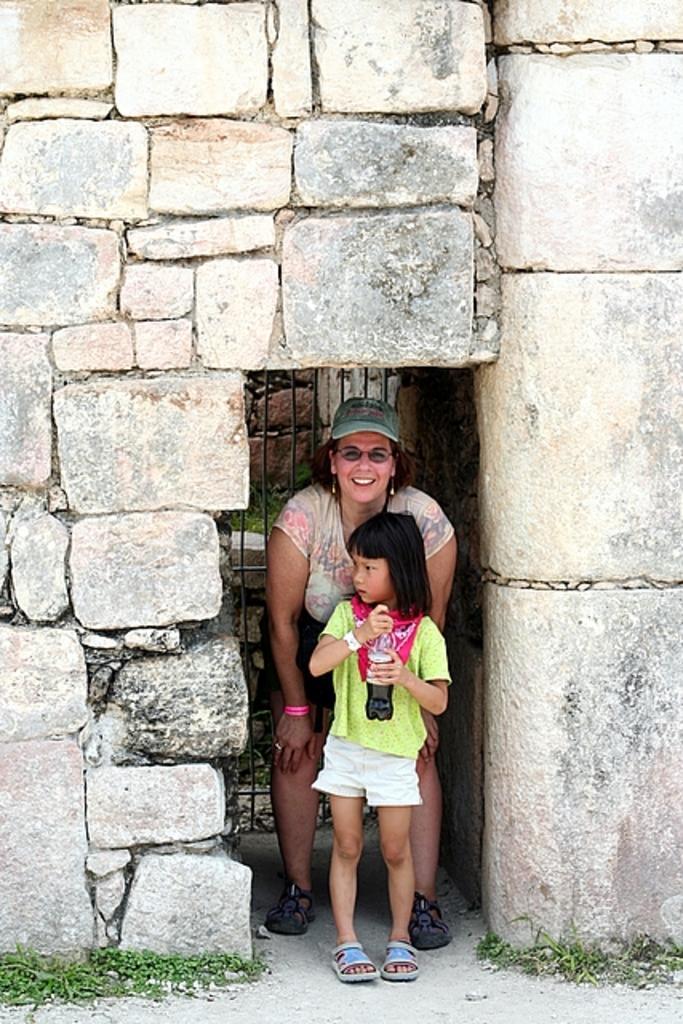Please provide a concise description of this image. In the image we can see a woman and a child. They are wearing clothes and the woman is wearing a cap, spectacles, earrings, finger ring and shoes, and the child is holding the bottle in the hands. Here we can see the stone wall, fence and the grass. 